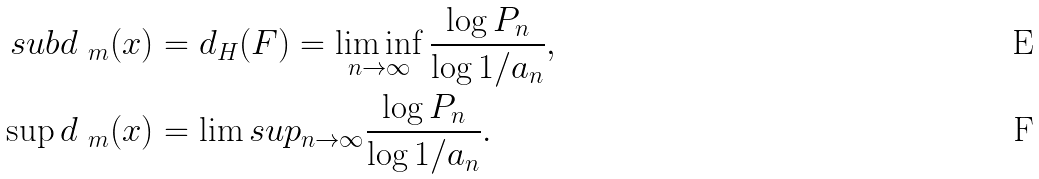Convert formula to latex. <formula><loc_0><loc_0><loc_500><loc_500>\ s u b d _ { \ m } ( x ) & = d _ { H } ( F ) = \liminf _ { n \to \infty } \frac { \log P _ { n } } { \log 1 / \L a _ { n } } , \\ \sup d _ { \ m } ( x ) & = \lim s u p _ { n \to \infty } \frac { \log P _ { n } } { \log 1 / \L a _ { n } } .</formula> 